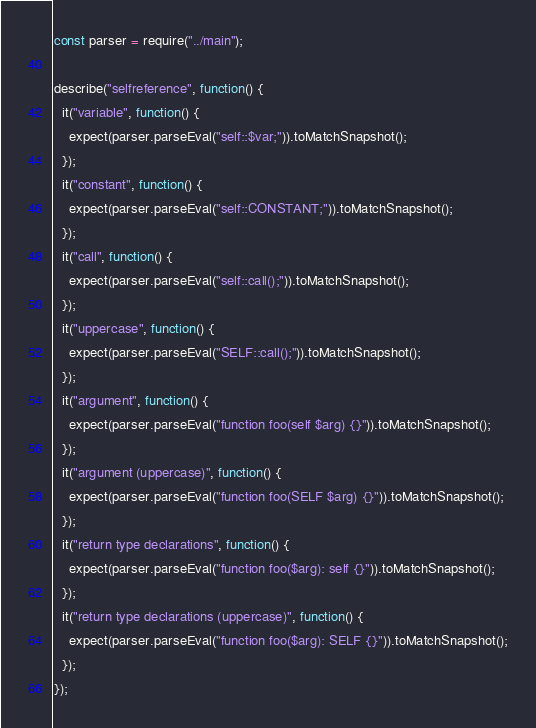<code> <loc_0><loc_0><loc_500><loc_500><_JavaScript_>const parser = require("../main");

describe("selfreference", function() {
  it("variable", function() {
    expect(parser.parseEval("self::$var;")).toMatchSnapshot();
  });
  it("constant", function() {
    expect(parser.parseEval("self::CONSTANT;")).toMatchSnapshot();
  });
  it("call", function() {
    expect(parser.parseEval("self::call();")).toMatchSnapshot();
  });
  it("uppercase", function() {
    expect(parser.parseEval("SELF::call();")).toMatchSnapshot();
  });
  it("argument", function() {
    expect(parser.parseEval("function foo(self $arg) {}")).toMatchSnapshot();
  });
  it("argument (uppercase)", function() {
    expect(parser.parseEval("function foo(SELF $arg) {}")).toMatchSnapshot();
  });
  it("return type declarations", function() {
    expect(parser.parseEval("function foo($arg): self {}")).toMatchSnapshot();
  });
  it("return type declarations (uppercase)", function() {
    expect(parser.parseEval("function foo($arg): SELF {}")).toMatchSnapshot();
  });
});
</code> 